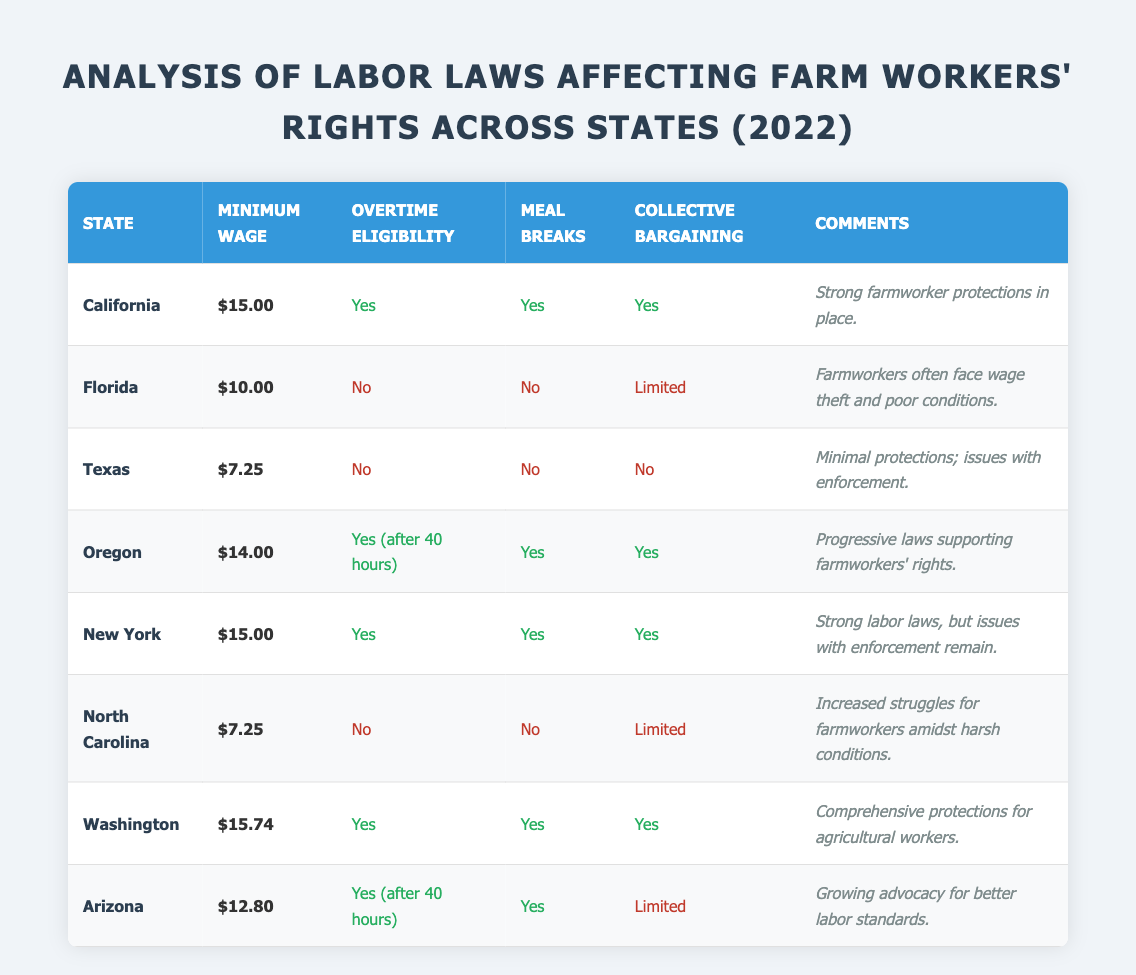What is the minimum wage in Washington? The table lists the minimum wage for Washington as $15.74.
Answer: $15.74 How many states in the table have a minimum wage of $15 or higher? The states with a minimum wage of $15 or higher are California, New York, and Washington. There are three such states.
Answer: 3 Which state has the strongest protections for farmworkers according to the comments? The comments for California state "Strong farmworker protections in place," indicating it has strong protections.
Answer: California Is meal break entitlement provided in Texas? The table indicates that meal breaks are listed as "No" for Texas, so entitlement is not provided.
Answer: No What is the average minimum wage of listed states? The minimum wages are $15.00 (California), $10.00 (Florida), $7.25 (Texas), $14.00 (Oregon), $15.00 (New York), $7.25 (North Carolina), $15.74 (Washington), and $12.80 (Arizona). Summing these gives $15.00 + $10.00 + $7.25 + $14.00 + $15.00 + $7.25 + $15.74 + $12.80 = $92.04. Dividing by 8 states gives an average of $11.51.
Answer: $11.51 Does Florida provide collective bargaining rights for farmworkers? The table shows that Florida's collective bargaining is categorized as "Limited," indicating rights are not fully available.
Answer: Limited In which states are meal breaks guaranteed for farmworkers? The states with guaranteed meal breaks are California, Oregon, New York, Washington, and Arizona, making it five states in total.
Answer: 5 What states do not provide any collective bargaining rights for farmworkers? The states without any collective bargaining rights are Texas and North Carolina. Thus, there are two such states.
Answer: 2 Which state has the highest wage, and what is it? The highest wage in the table is from Washington at $15.74.
Answer: $15.74 How many states lack overtime eligibility for farmworkers? The states without overtime eligibility are Florida, Texas, North Carolina, totaling three states.
Answer: 3 Is there a state where wages are below $10? Yes, Texas ($7.25) and North Carolina ($7.25) both have wages below $10.
Answer: Yes 